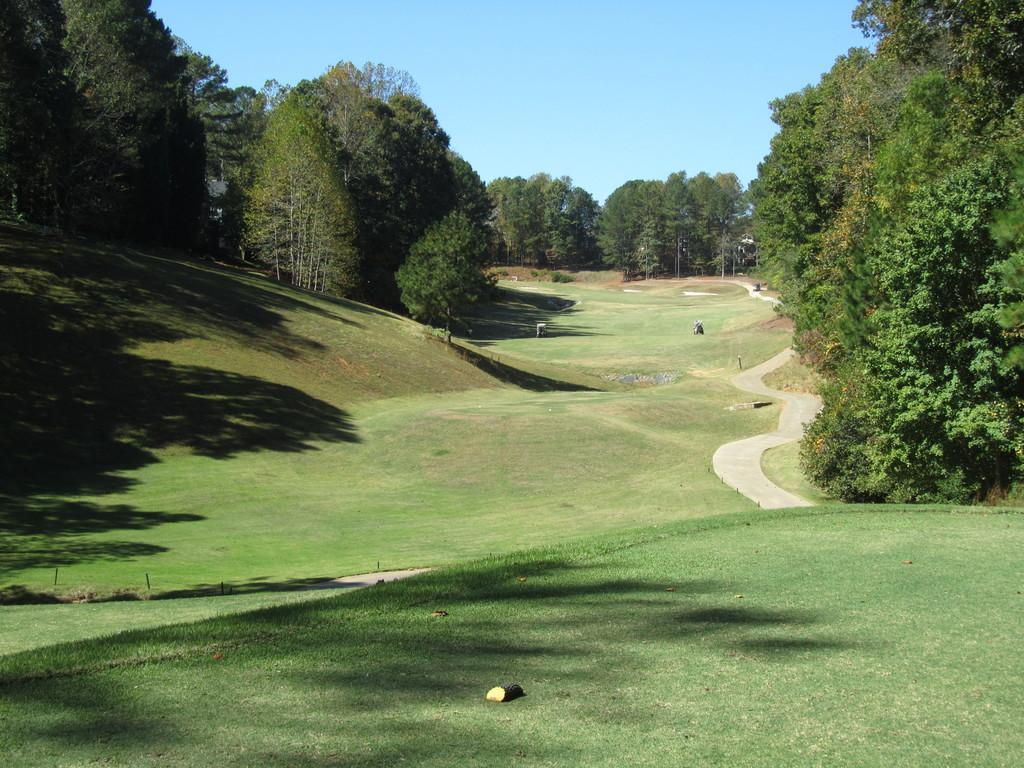What type of landscape is depicted in the image? There is a grassland in the image. Are there any other natural elements present in the image? Yes, there are trees in the image. What color is the sky in the background of the image? The sky is blue in the background of the image. What news is being discussed by the trees in the image? There are no people or animals present in the image, so there is no discussion or news being shared. 